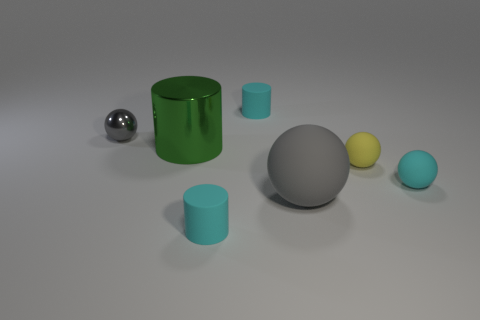Is there a tiny red ball made of the same material as the tiny gray ball?
Your answer should be compact. No. Is the cyan cylinder that is behind the cyan ball made of the same material as the big gray thing?
Keep it short and to the point. Yes. What is the size of the cyan thing that is to the left of the small yellow matte object and behind the gray rubber ball?
Provide a short and direct response. Small. What color is the big shiny cylinder?
Ensure brevity in your answer.  Green. What number of large blue matte spheres are there?
Make the answer very short. 0. How many small objects are the same color as the large matte sphere?
Your answer should be very brief. 1. There is a gray object to the right of the small gray thing; is it the same shape as the gray object to the left of the green cylinder?
Your answer should be compact. Yes. What color is the matte cylinder in front of the cyan matte object on the right side of the small cyan thing that is behind the green object?
Your answer should be very brief. Cyan. What is the color of the matte cylinder that is behind the metal ball?
Your response must be concise. Cyan. There is another rubber sphere that is the same size as the yellow matte sphere; what is its color?
Offer a very short reply. Cyan. 